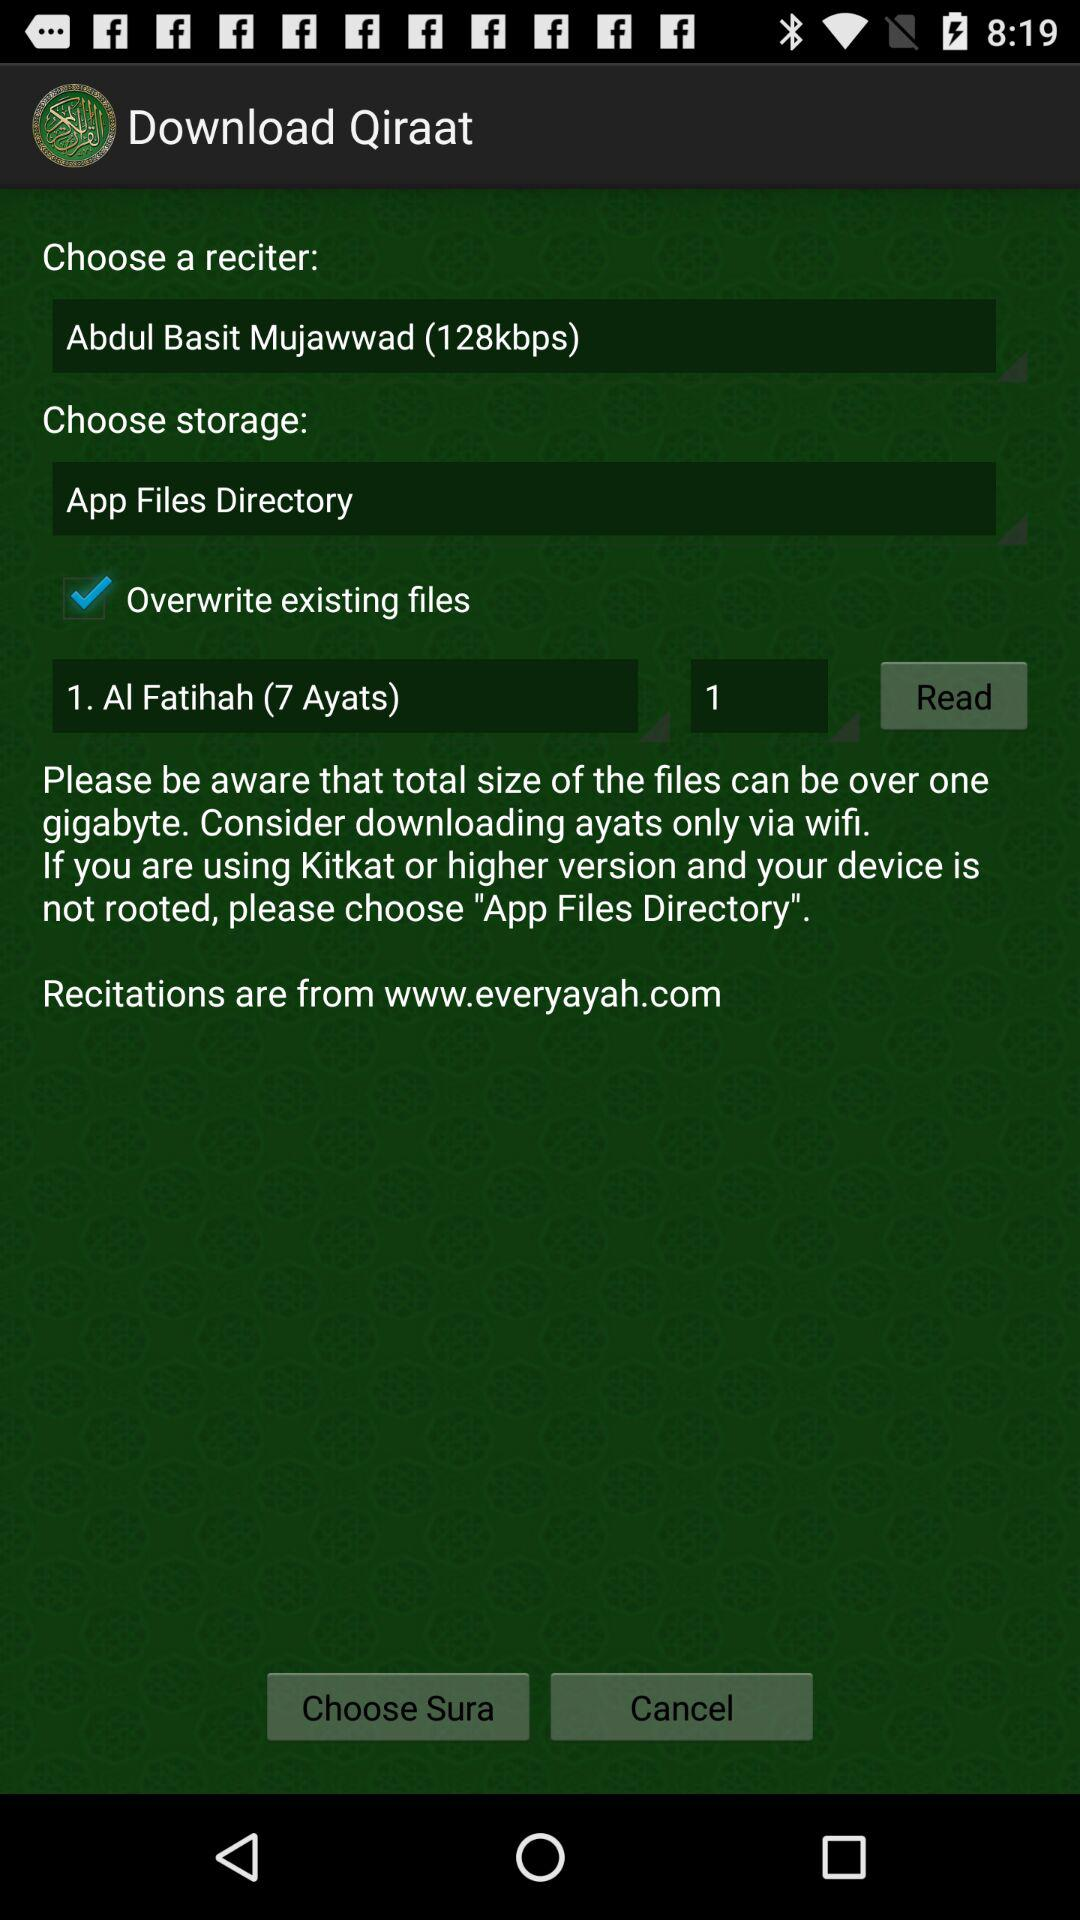How many ayats are there in the sura that is currently selected?
Answer the question using a single word or phrase. 7 